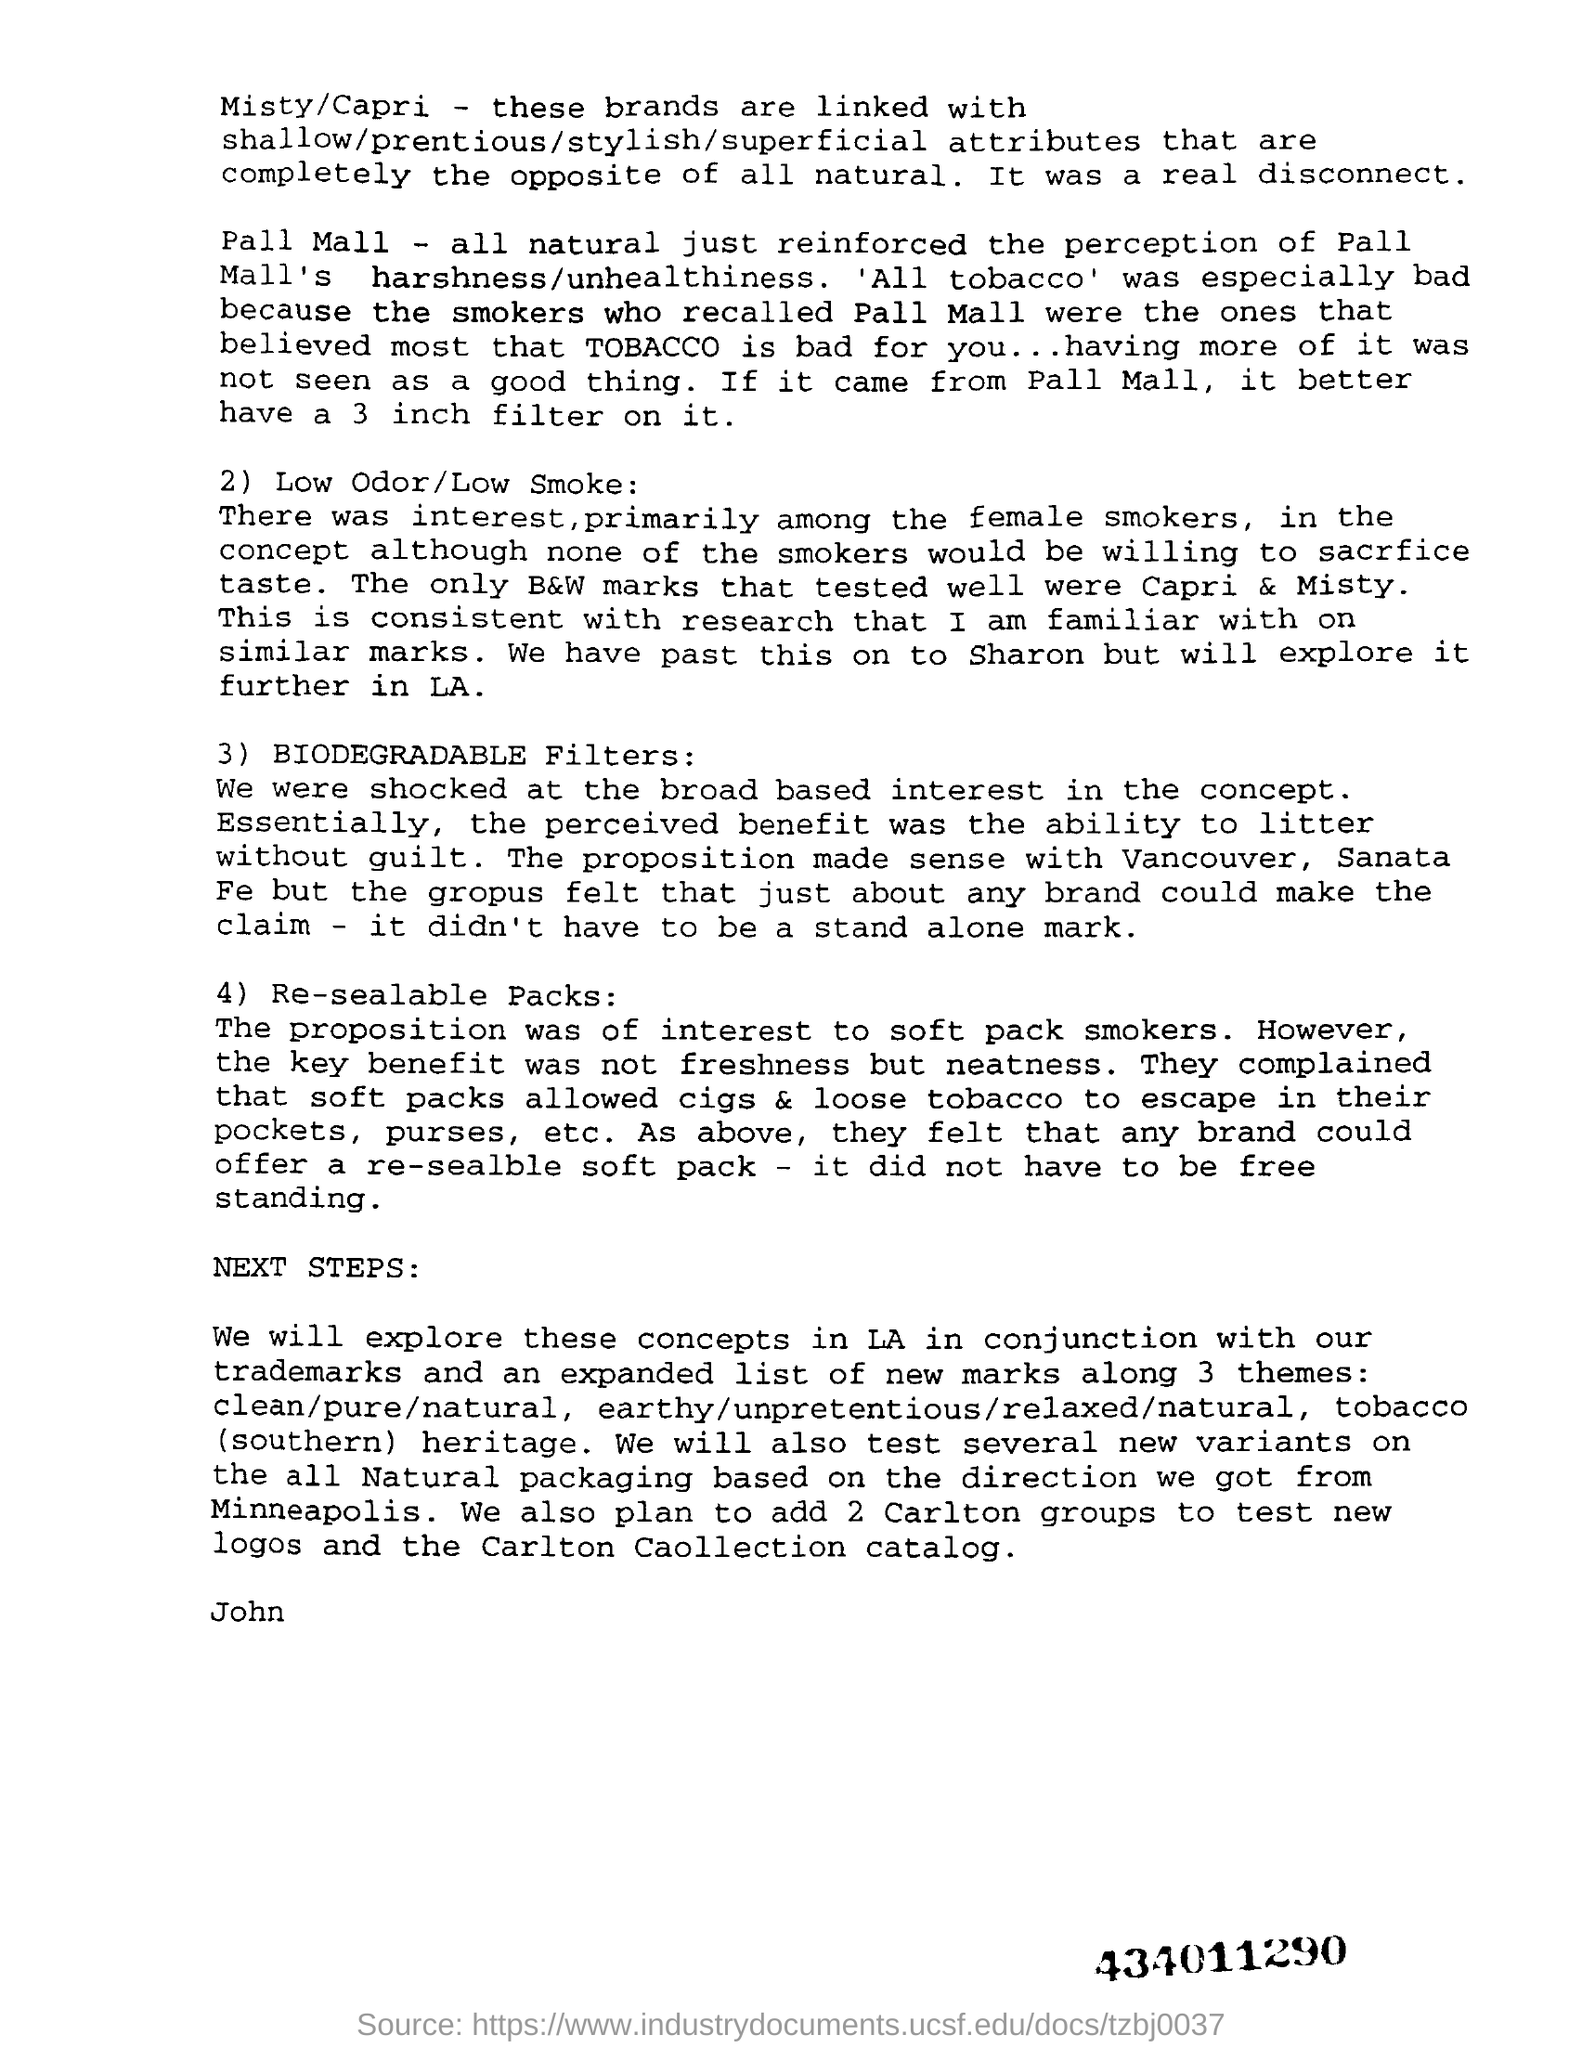What is the number at bottom right corner of the page ?
Provide a short and direct response. 434011290. How many inches of filter is better if it is from pall mall ?
Offer a very short reply. 3 inch. 